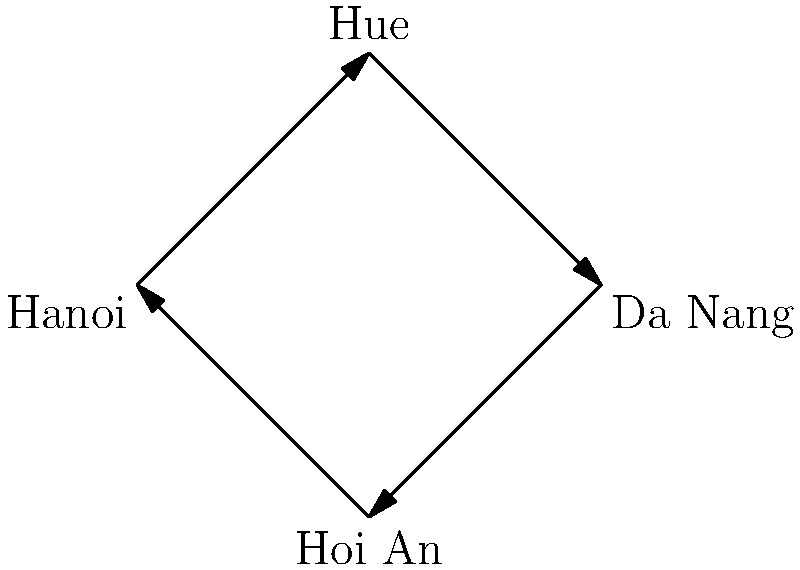Consider a tour route connecting four historical landmarks in Vietnam: Hanoi, Hue, Da Nang, and Hoi An, as shown in the diagram. If we represent each possible tour route as a permutation of these four cities, what is the order of the permutation group formed by all possible tour routes starting and ending in Hanoi? Let's approach this step-by-step:

1) First, we need to understand what the question is asking. We're looking for the order of the permutation group, which is the number of unique permutations possible.

2) In this case, we're considering tours that start and end in Hanoi. This means Hanoi is fixed as the first and last city in our permutation.

3) We now need to arrange the other three cities (Hue, Da Nang, and Hoi An) in all possible ways.

4) This is a classic permutation problem. The number of ways to arrange n distinct objects is n!.

5) In this case, we have 3 cities to arrange, so the number of permutations is 3! = 3 × 2 × 1 = 6.

6) Therefore, there are 6 possible unique tour routes starting and ending in Hanoi.

7) In group theory, the order of a group is the number of elements in the group. Here, each unique tour route represents an element of our permutation group.

8) Thus, the order of the permutation group formed by all possible tour routes starting and ending in Hanoi is 6.
Answer: 6 